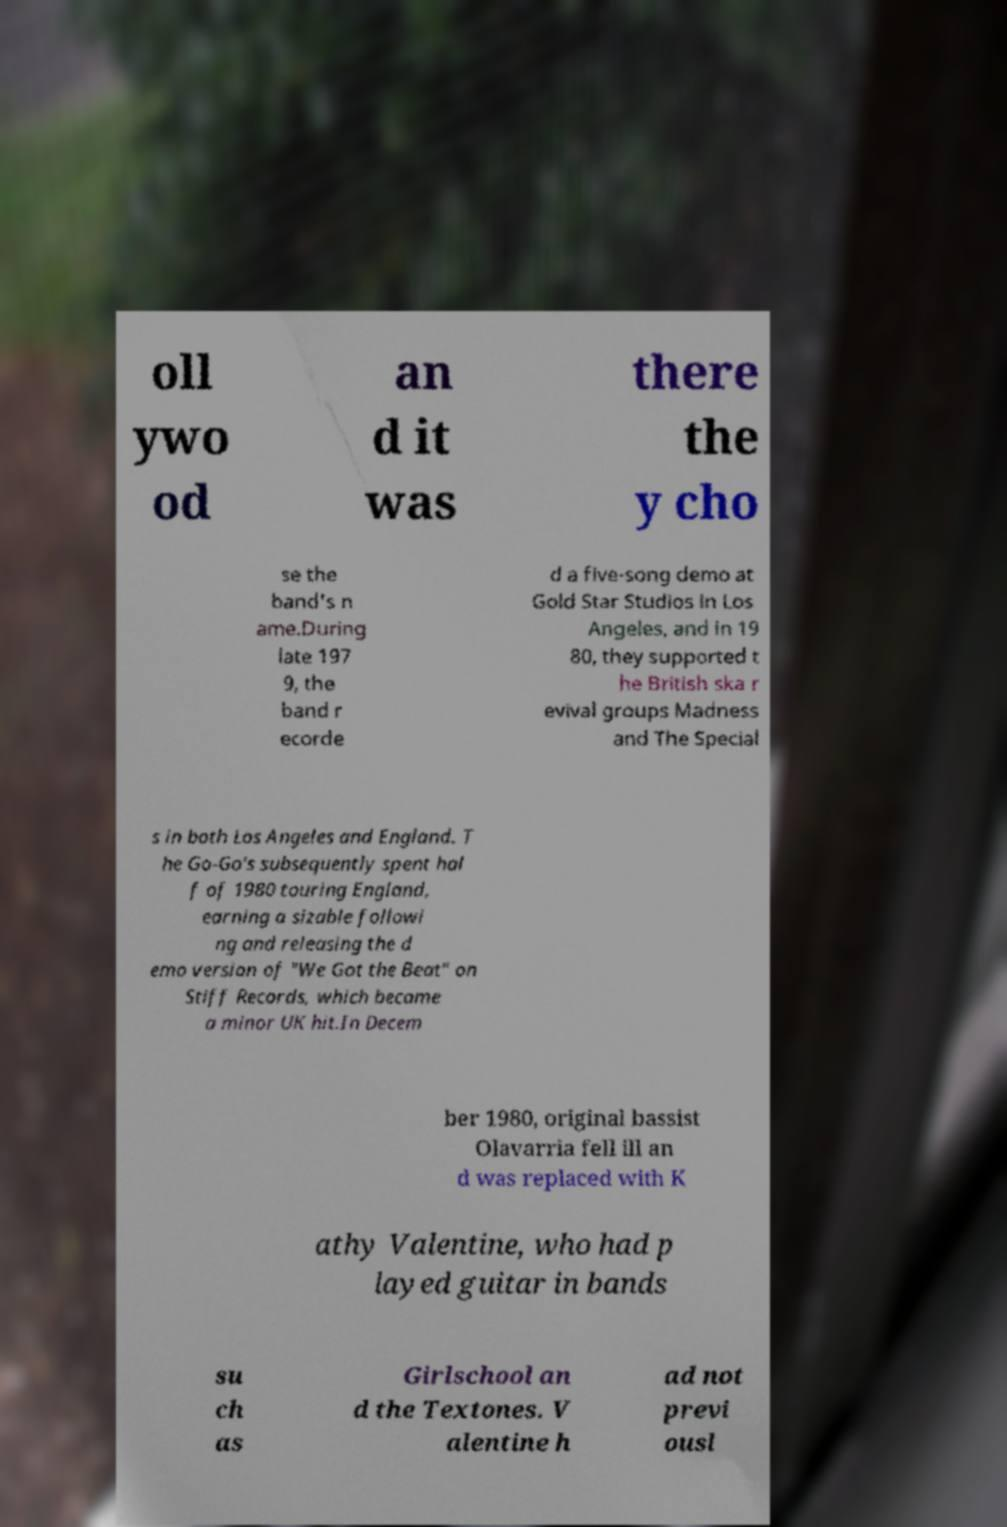Could you assist in decoding the text presented in this image and type it out clearly? oll ywo od an d it was there the y cho se the band's n ame.During late 197 9, the band r ecorde d a five-song demo at Gold Star Studios in Los Angeles, and in 19 80, they supported t he British ska r evival groups Madness and The Special s in both Los Angeles and England. T he Go-Go's subsequently spent hal f of 1980 touring England, earning a sizable followi ng and releasing the d emo version of "We Got the Beat" on Stiff Records, which became a minor UK hit.In Decem ber 1980, original bassist Olavarria fell ill an d was replaced with K athy Valentine, who had p layed guitar in bands su ch as Girlschool an d the Textones. V alentine h ad not previ ousl 